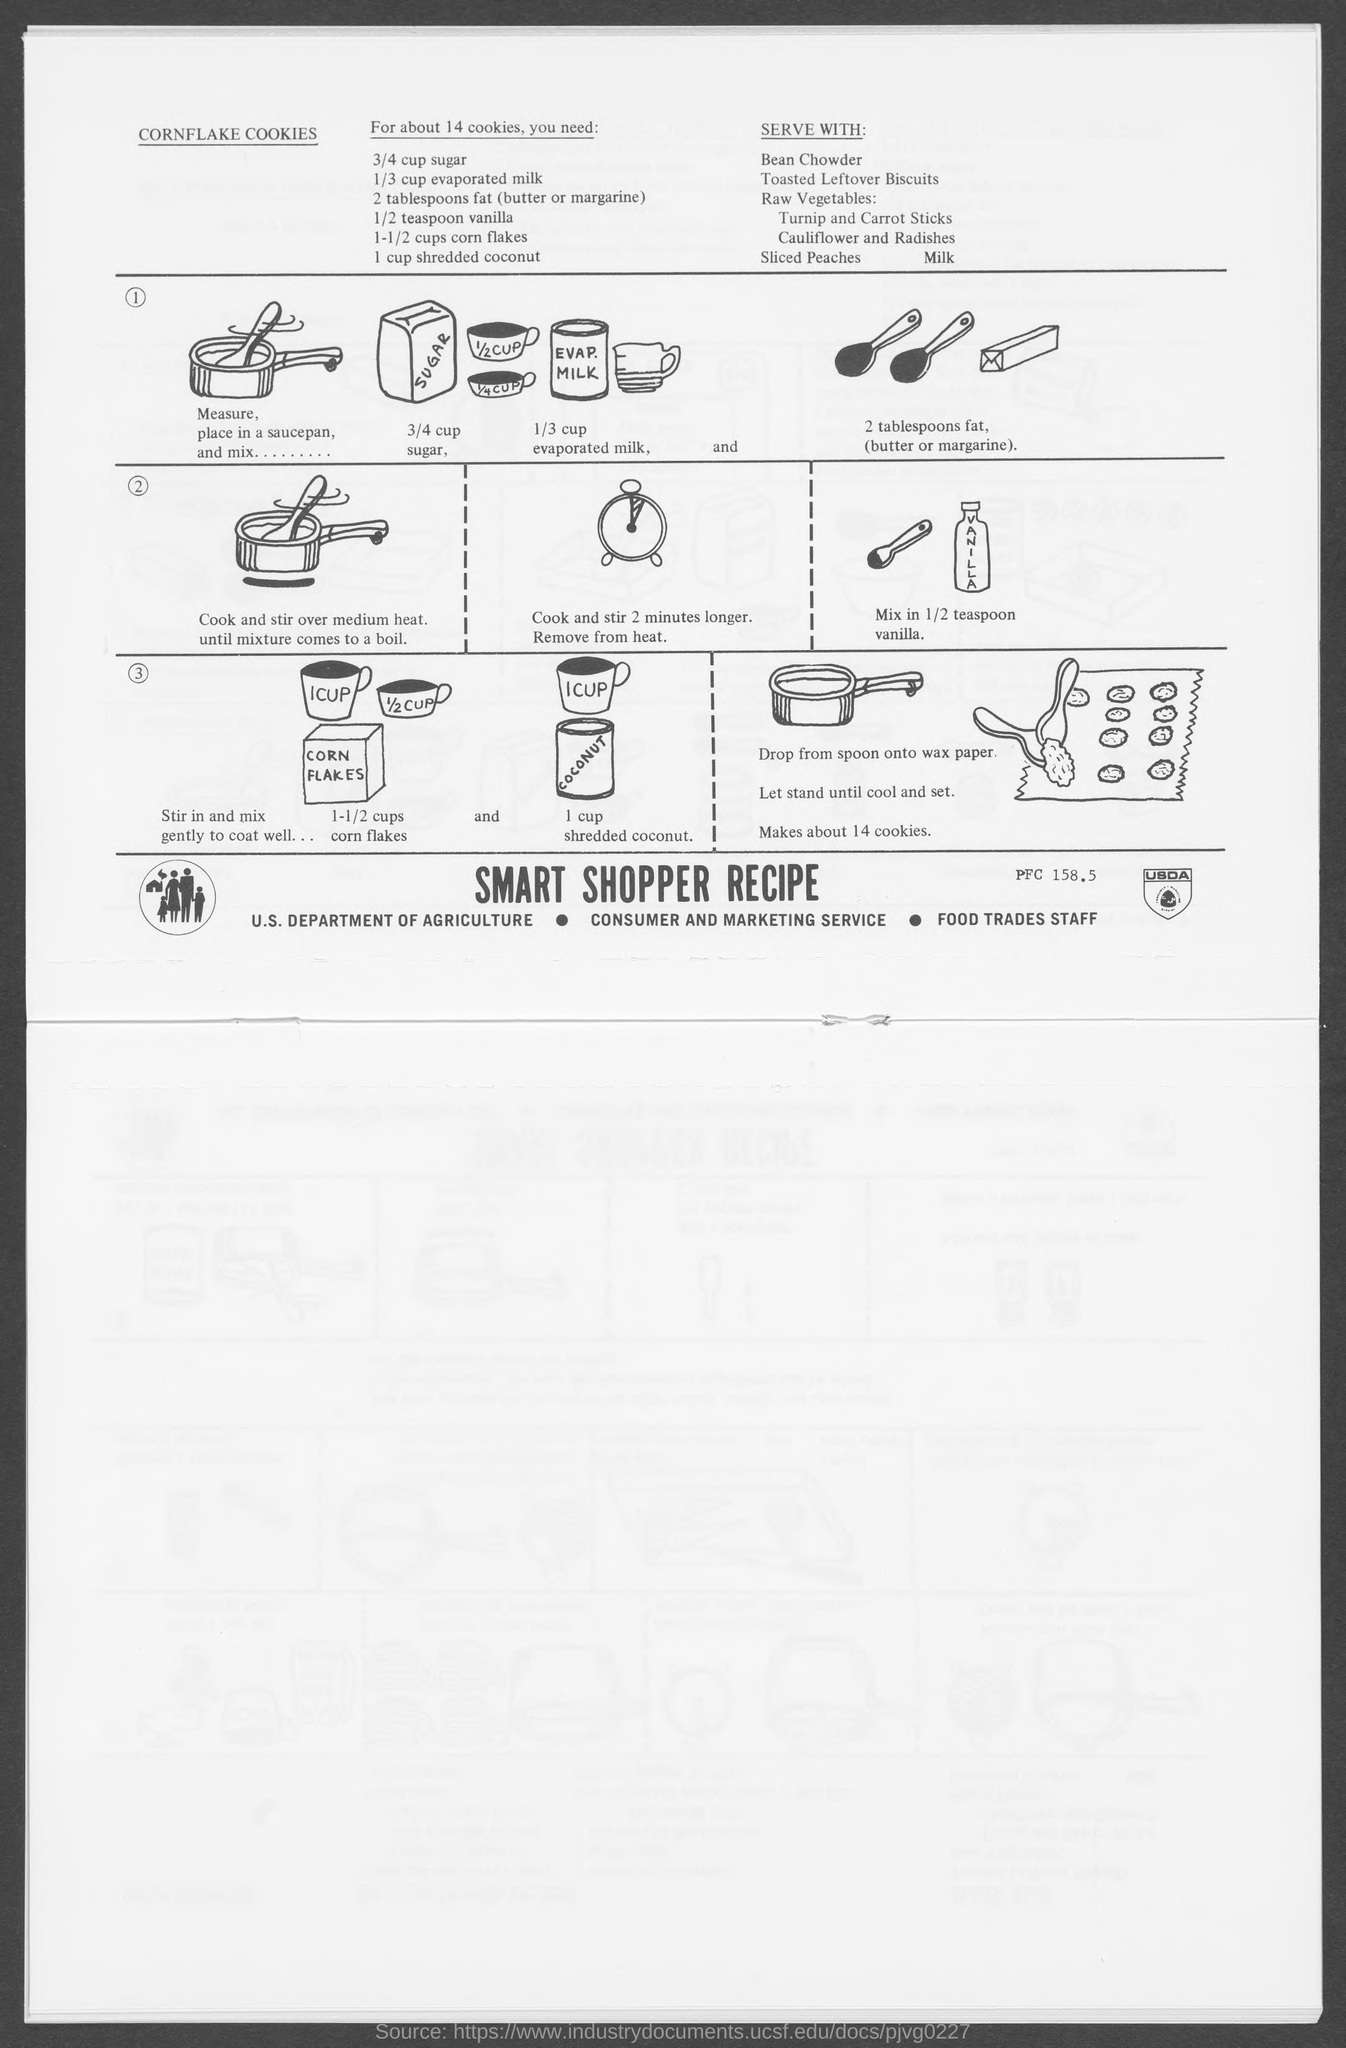What is the recipe for?
Provide a short and direct response. Cornflake cookies. How much sugar?
Provide a short and direct response. 3/4 cup sugar. How much evaporated milk?
Provide a succinct answer. 1/3 cup. How much fat?
Offer a very short reply. 2 tablespoons fat. 